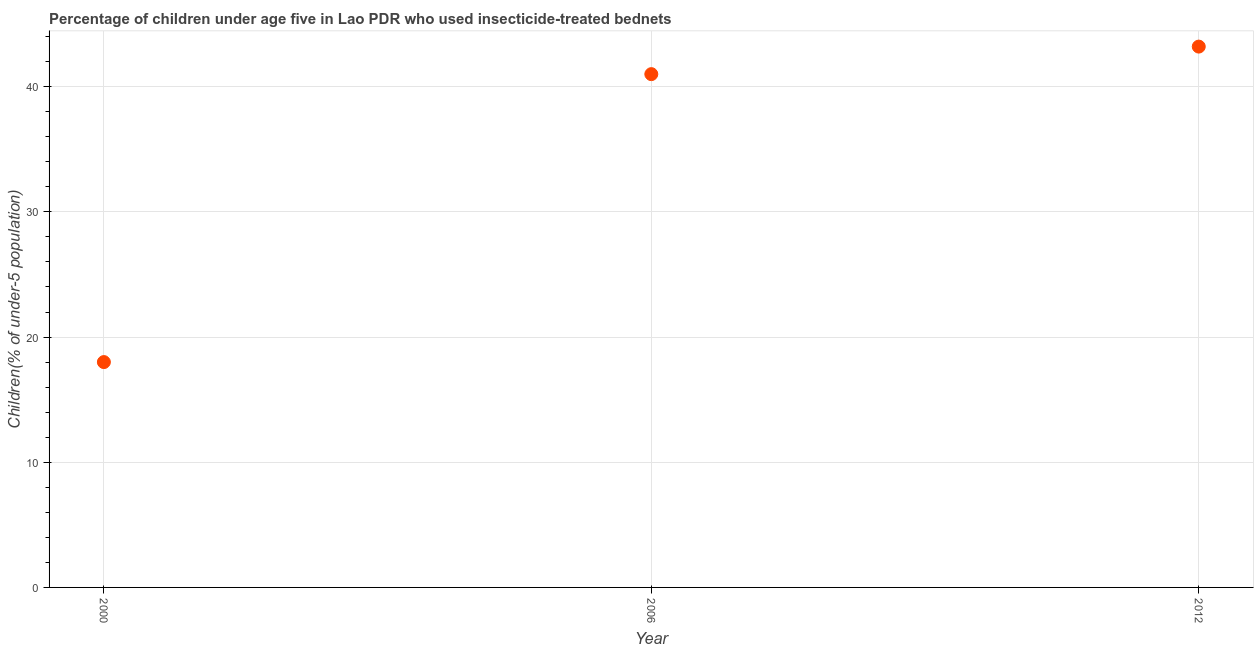Across all years, what is the maximum percentage of children who use of insecticide-treated bed nets?
Your answer should be compact. 43.2. In which year was the percentage of children who use of insecticide-treated bed nets minimum?
Give a very brief answer. 2000. What is the sum of the percentage of children who use of insecticide-treated bed nets?
Give a very brief answer. 102.2. What is the difference between the percentage of children who use of insecticide-treated bed nets in 2006 and 2012?
Your answer should be compact. -2.2. What is the average percentage of children who use of insecticide-treated bed nets per year?
Your answer should be very brief. 34.07. In how many years, is the percentage of children who use of insecticide-treated bed nets greater than 28 %?
Your response must be concise. 2. What is the ratio of the percentage of children who use of insecticide-treated bed nets in 2000 to that in 2006?
Offer a very short reply. 0.44. Is the percentage of children who use of insecticide-treated bed nets in 2000 less than that in 2012?
Keep it short and to the point. Yes. Is the difference between the percentage of children who use of insecticide-treated bed nets in 2000 and 2006 greater than the difference between any two years?
Provide a short and direct response. No. What is the difference between the highest and the second highest percentage of children who use of insecticide-treated bed nets?
Your answer should be very brief. 2.2. Is the sum of the percentage of children who use of insecticide-treated bed nets in 2000 and 2012 greater than the maximum percentage of children who use of insecticide-treated bed nets across all years?
Provide a succinct answer. Yes. What is the difference between the highest and the lowest percentage of children who use of insecticide-treated bed nets?
Offer a terse response. 25.2. In how many years, is the percentage of children who use of insecticide-treated bed nets greater than the average percentage of children who use of insecticide-treated bed nets taken over all years?
Give a very brief answer. 2. Does the percentage of children who use of insecticide-treated bed nets monotonically increase over the years?
Offer a very short reply. Yes. How many dotlines are there?
Provide a short and direct response. 1. Does the graph contain grids?
Provide a succinct answer. Yes. What is the title of the graph?
Keep it short and to the point. Percentage of children under age five in Lao PDR who used insecticide-treated bednets. What is the label or title of the Y-axis?
Offer a terse response. Children(% of under-5 population). What is the Children(% of under-5 population) in 2000?
Your response must be concise. 18. What is the Children(% of under-5 population) in 2012?
Your answer should be compact. 43.2. What is the difference between the Children(% of under-5 population) in 2000 and 2012?
Offer a terse response. -25.2. What is the difference between the Children(% of under-5 population) in 2006 and 2012?
Your response must be concise. -2.2. What is the ratio of the Children(% of under-5 population) in 2000 to that in 2006?
Your response must be concise. 0.44. What is the ratio of the Children(% of under-5 population) in 2000 to that in 2012?
Make the answer very short. 0.42. What is the ratio of the Children(% of under-5 population) in 2006 to that in 2012?
Ensure brevity in your answer.  0.95. 